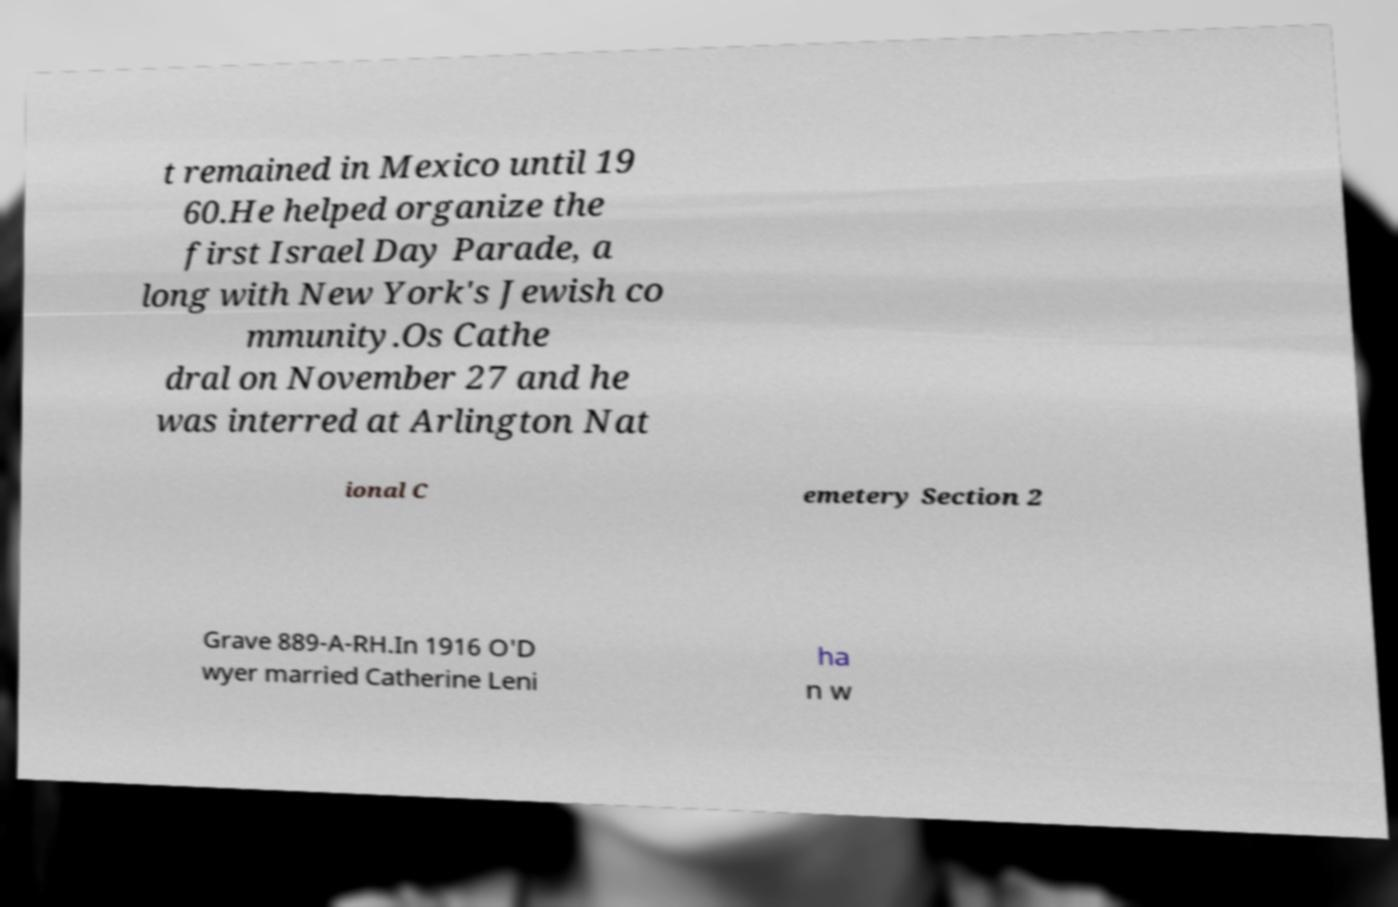Could you extract and type out the text from this image? t remained in Mexico until 19 60.He helped organize the first Israel Day Parade, a long with New York's Jewish co mmunity.Os Cathe dral on November 27 and he was interred at Arlington Nat ional C emetery Section 2 Grave 889-A-RH.In 1916 O'D wyer married Catherine Leni ha n w 